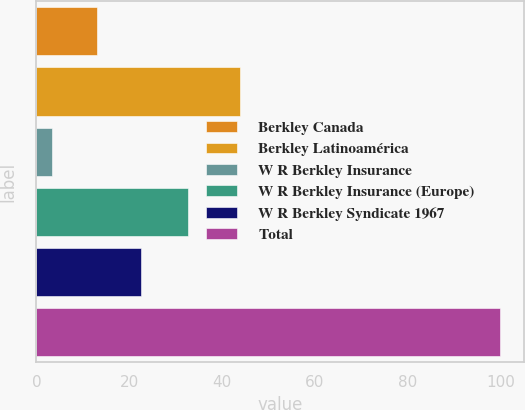Convert chart to OTSL. <chart><loc_0><loc_0><loc_500><loc_500><bar_chart><fcel>Berkley Canada<fcel>Berkley Latinoamérica<fcel>W R Berkley Insurance<fcel>W R Berkley Insurance (Europe)<fcel>W R Berkley Syndicate 1967<fcel>Total<nl><fcel>12.97<fcel>43.8<fcel>3.3<fcel>32.7<fcel>22.64<fcel>100<nl></chart> 